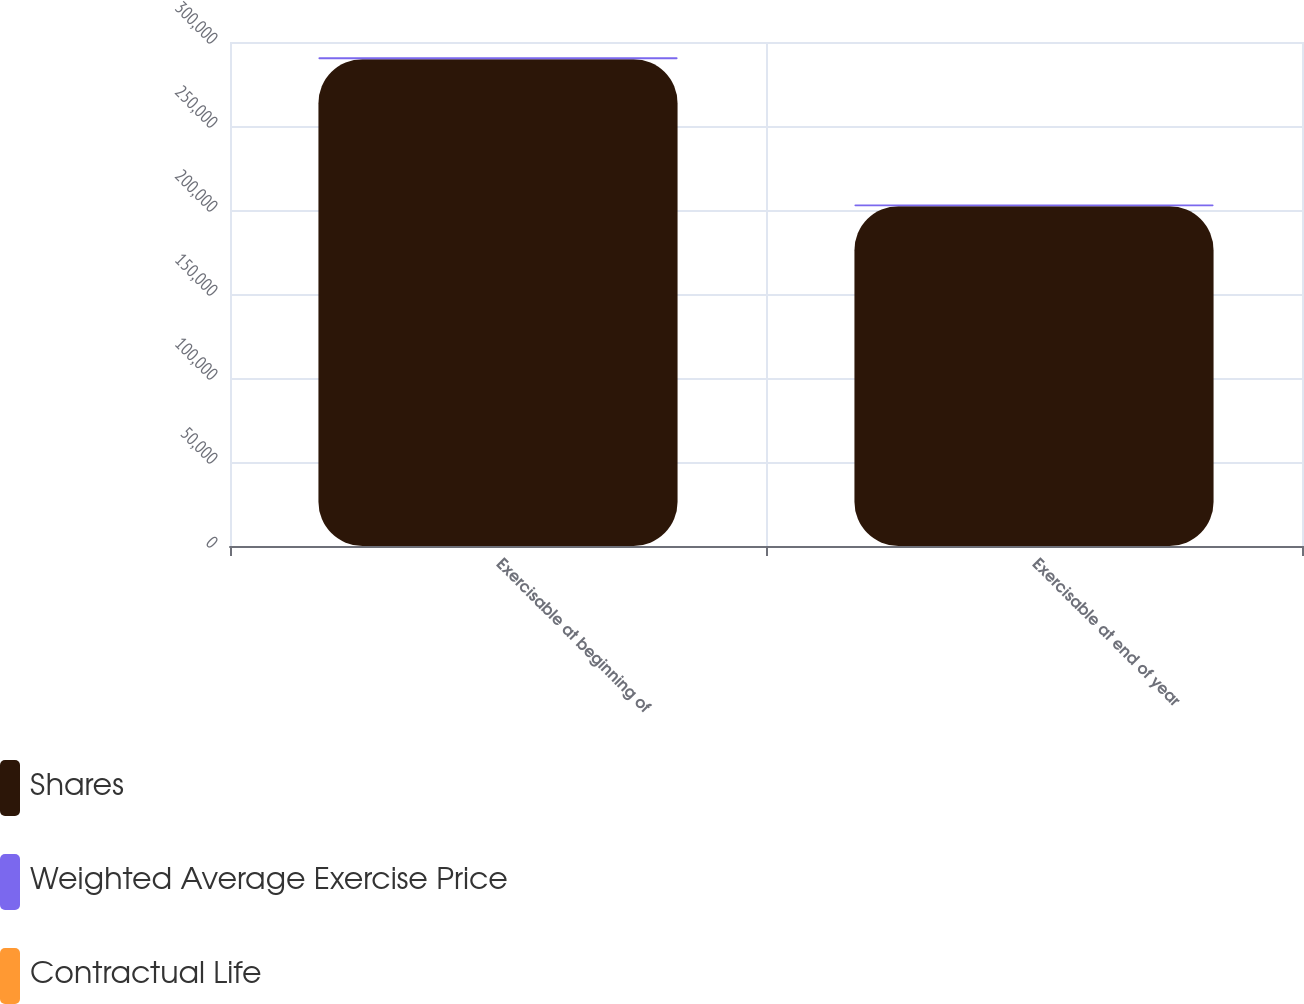<chart> <loc_0><loc_0><loc_500><loc_500><stacked_bar_chart><ecel><fcel>Exercisable at beginning of<fcel>Exercisable at end of year<nl><fcel>Shares<fcel>289790<fcel>202275<nl><fcel>Weighted Average Exercise Price<fcel>1113.99<fcel>1037.74<nl><fcel>Contractual Life<fcel>2.58<fcel>2.17<nl></chart> 